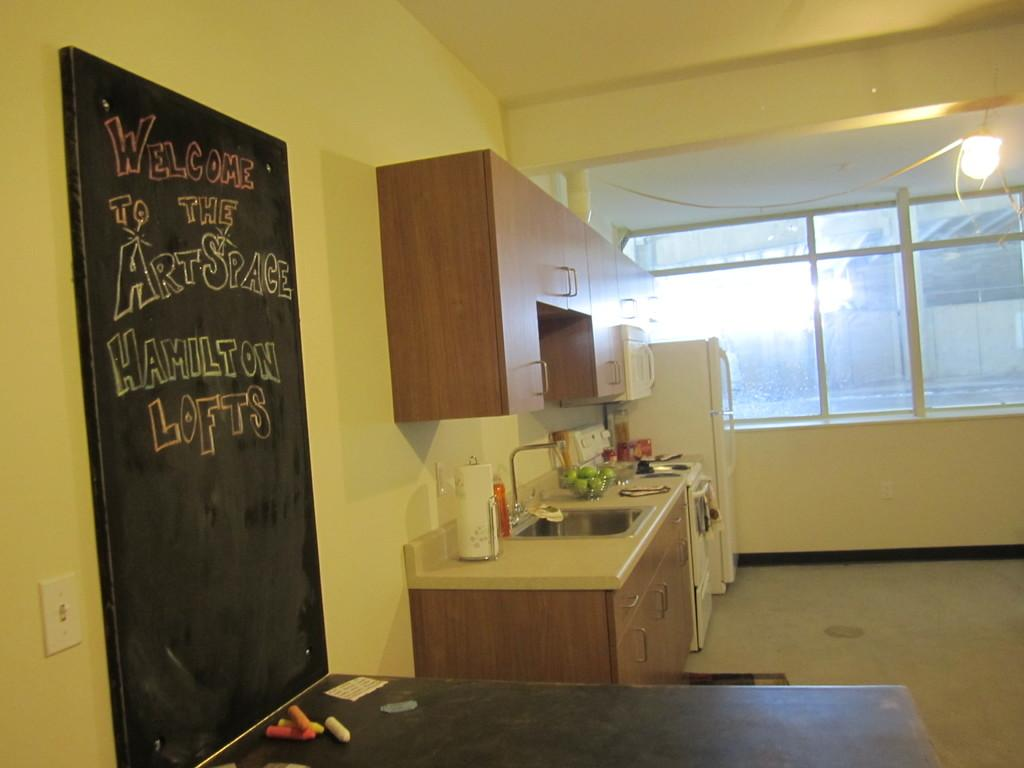<image>
Offer a succinct explanation of the picture presented. A kitchen has a black chalkboard that says Welcome to the Art Space Hamilton Lofts. 